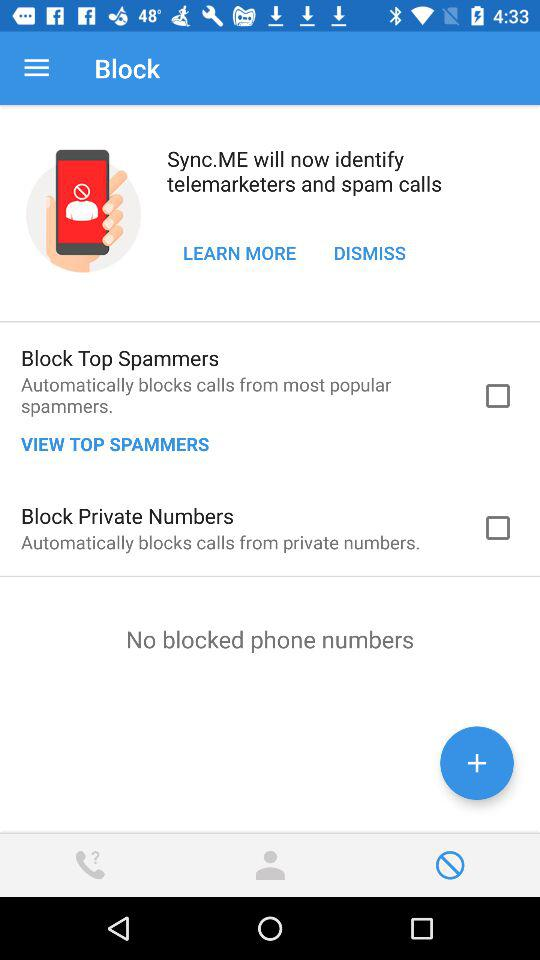What is the selected tab? The selected tab is "Block". 